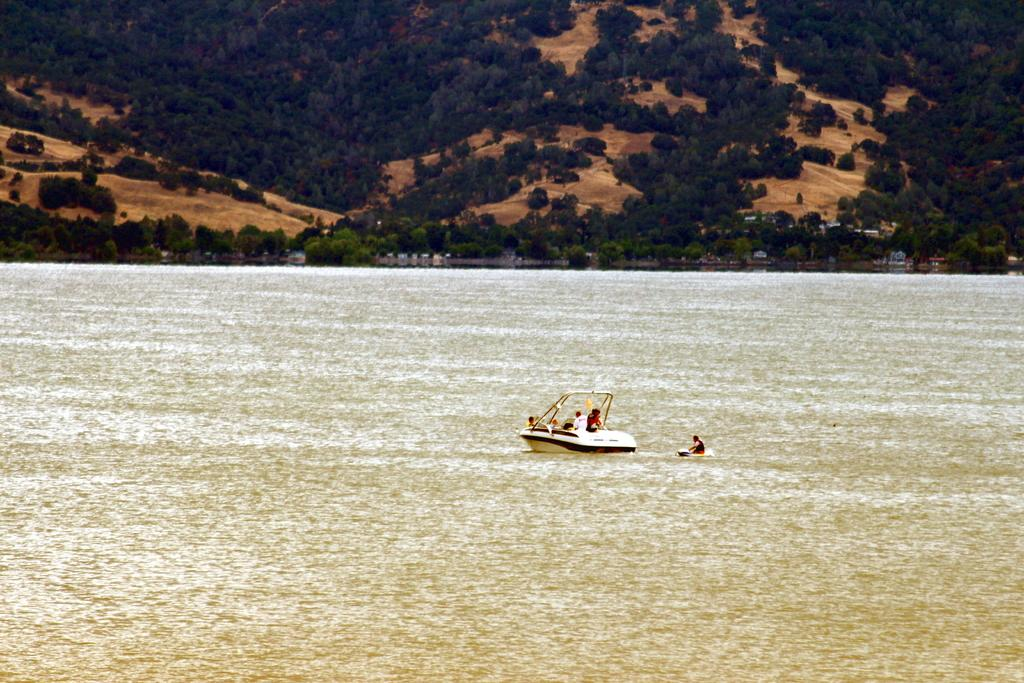What are the persons in the image doing? The persons in the image are sailing on a boat. What can be seen in the background of the image? There is water, trees, and a hill visible in the background of the image. What type of bell can be heard ringing in the image? There is no bell present in the image, and therefore no sound can be heard. 